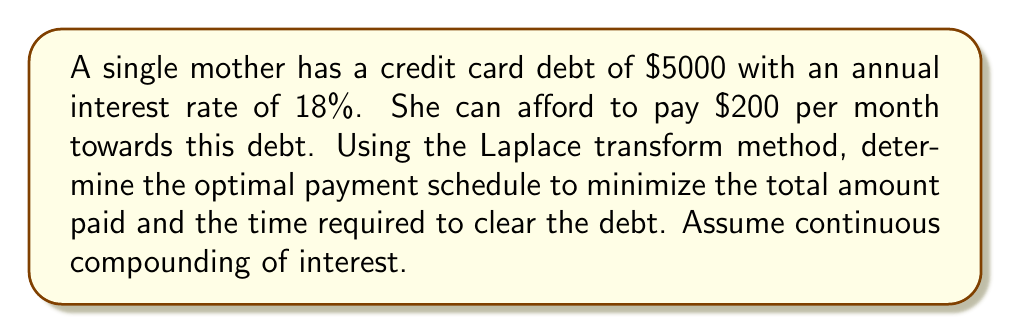Teach me how to tackle this problem. Let's approach this problem step-by-step using the Laplace transform method:

1) First, we need to set up the differential equation that describes the debt balance over time:

   $$\frac{dB}{dt} = rB - P$$

   where $B$ is the balance, $r$ is the interest rate, and $P$ is the monthly payment.

2) We have $r = 0.18$ (18% annual rate) and $P = 200$ (monthly payment).

3) Taking the Laplace transform of both sides:

   $$s\mathcal{L}\{B\} - B(0) = r\mathcal{L}\{B\} - \frac{P}{s}$$

   where $B(0) = 5000$ is the initial debt.

4) Solving for $\mathcal{L}\{B\}$:

   $$\mathcal{L}\{B\} = \frac{B(0)}{s-r} + \frac{P}{s(s-r)}$$

5) Taking the inverse Laplace transform:

   $$B(t) = B(0)e^{rt} + \frac{P}{r}(e^{rt} - 1)$$

6) To find the time $T$ when the debt is fully paid, we set $B(T) = 0$:

   $$0 = 5000e^{0.18T} + \frac{200}{0.18}(e^{0.18T} - 1)$$

7) Solving this equation numerically (as it can't be solved analytically), we get:

   $$T \approx 2.76 \text{ years}$$

8) The total amount paid is:

   $$\text{Total Paid} = 200 \times 12 \times 2.76 = 6624$$

Therefore, the optimal payment schedule is to pay $200 per month for approximately 2.76 years.
Answer: The optimal payment schedule is to pay $200 per month for approximately 2.76 years. The total amount paid will be $6624. 